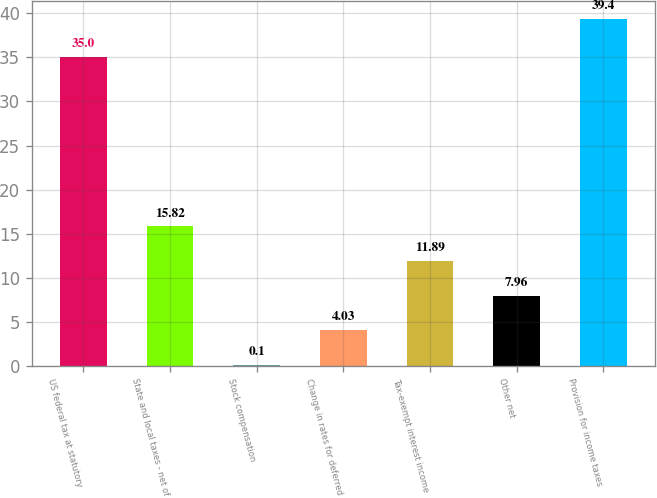<chart> <loc_0><loc_0><loc_500><loc_500><bar_chart><fcel>US federal tax at statutory<fcel>State and local taxes - net of<fcel>Stock compensation<fcel>Change in rates for deferred<fcel>Tax-exempt interest income<fcel>Other net<fcel>Provision for income taxes<nl><fcel>35<fcel>15.82<fcel>0.1<fcel>4.03<fcel>11.89<fcel>7.96<fcel>39.4<nl></chart> 